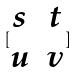<formula> <loc_0><loc_0><loc_500><loc_500>[ \begin{matrix} s & t \\ u & v \end{matrix} ]</formula> 